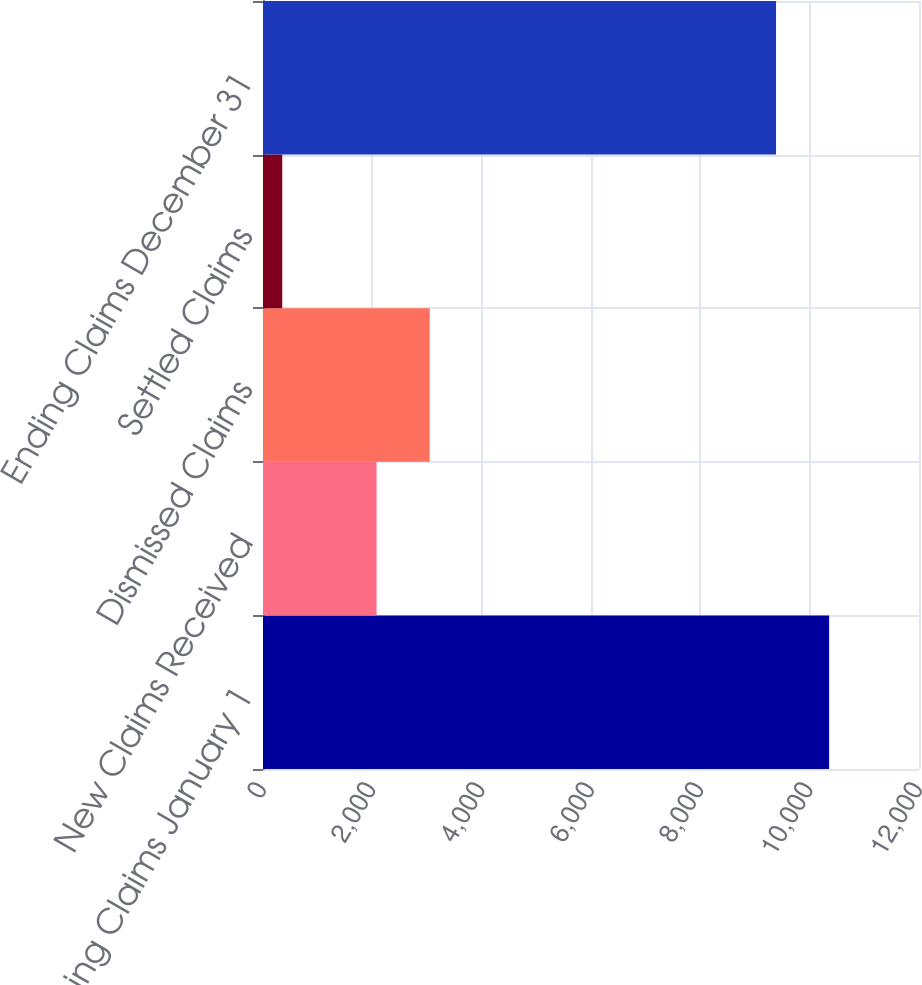Convert chart to OTSL. <chart><loc_0><loc_0><loc_500><loc_500><bar_chart><fcel>Beginning Claims January 1<fcel>New Claims Received<fcel>Dismissed Claims<fcel>Settled Claims<fcel>Ending Claims December 31<nl><fcel>10355.9<fcel>2078<fcel>3048.9<fcel>352<fcel>9385<nl></chart> 